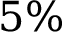Convert formula to latex. <formula><loc_0><loc_0><loc_500><loc_500>5 \%</formula> 